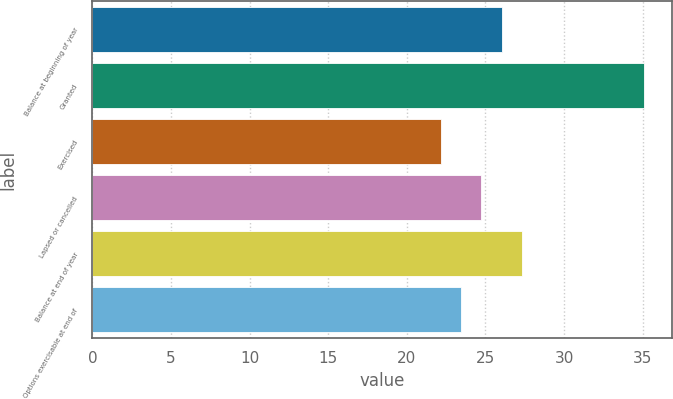Convert chart to OTSL. <chart><loc_0><loc_0><loc_500><loc_500><bar_chart><fcel>Balance at beginning of year<fcel>Granted<fcel>Exercised<fcel>Lapsed or cancelled<fcel>Balance at end of year<fcel>Options exercisable at end of<nl><fcel>26.04<fcel>35.09<fcel>22.14<fcel>24.74<fcel>27.34<fcel>23.44<nl></chart> 